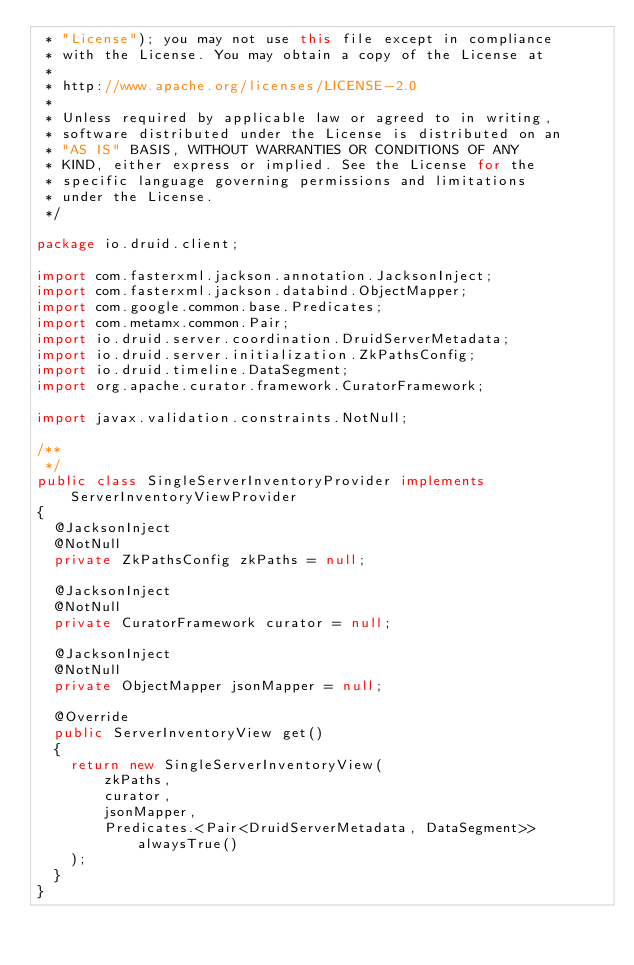<code> <loc_0><loc_0><loc_500><loc_500><_Java_> * "License"); you may not use this file except in compliance
 * with the License. You may obtain a copy of the License at
 *
 * http://www.apache.org/licenses/LICENSE-2.0
 *
 * Unless required by applicable law or agreed to in writing,
 * software distributed under the License is distributed on an
 * "AS IS" BASIS, WITHOUT WARRANTIES OR CONDITIONS OF ANY
 * KIND, either express or implied. See the License for the
 * specific language governing permissions and limitations
 * under the License.
 */

package io.druid.client;

import com.fasterxml.jackson.annotation.JacksonInject;
import com.fasterxml.jackson.databind.ObjectMapper;
import com.google.common.base.Predicates;
import com.metamx.common.Pair;
import io.druid.server.coordination.DruidServerMetadata;
import io.druid.server.initialization.ZkPathsConfig;
import io.druid.timeline.DataSegment;
import org.apache.curator.framework.CuratorFramework;

import javax.validation.constraints.NotNull;

/**
 */
public class SingleServerInventoryProvider implements ServerInventoryViewProvider
{
  @JacksonInject
  @NotNull
  private ZkPathsConfig zkPaths = null;

  @JacksonInject
  @NotNull
  private CuratorFramework curator = null;

  @JacksonInject
  @NotNull
  private ObjectMapper jsonMapper = null;

  @Override
  public ServerInventoryView get()
  {
    return new SingleServerInventoryView(
        zkPaths,
        curator,
        jsonMapper,
        Predicates.<Pair<DruidServerMetadata, DataSegment>>alwaysTrue()
    );
  }
}
</code> 